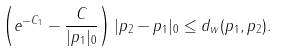<formula> <loc_0><loc_0><loc_500><loc_500>\left ( e ^ { - C _ { 1 } } - \frac { C } { | p _ { 1 } | _ { 0 } } \right ) | p _ { 2 } - p _ { 1 } | _ { 0 } \leq d _ { w } ( p _ { 1 } , p _ { 2 } ) .</formula> 